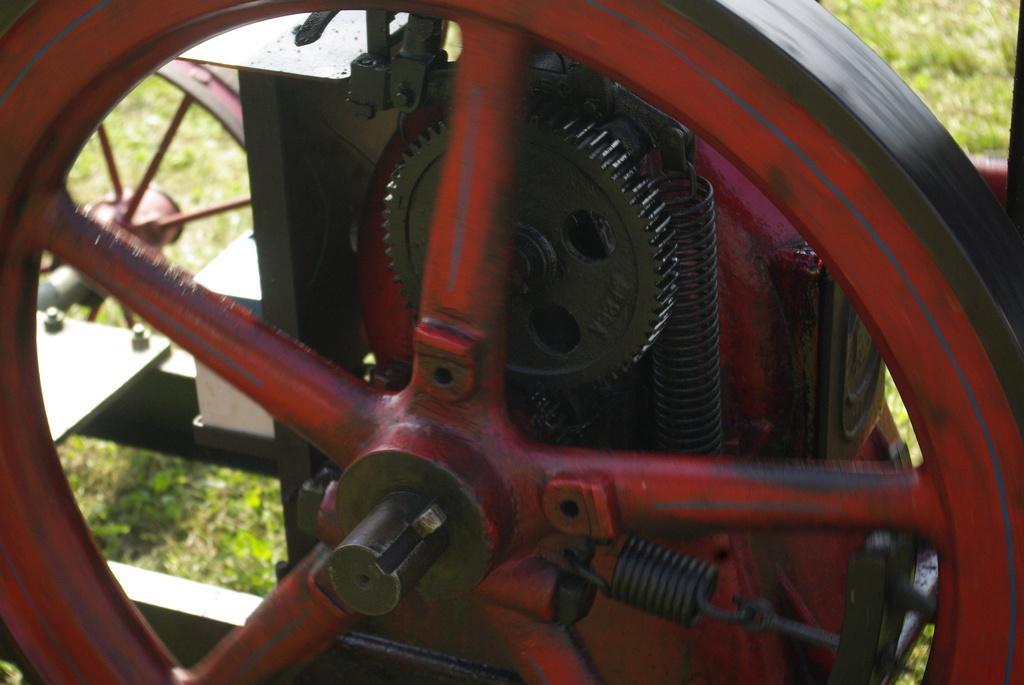In one or two sentences, can you explain what this image depicts? In this picture we can see a wheel, a gear and springs in the front, in the background there is grass. 